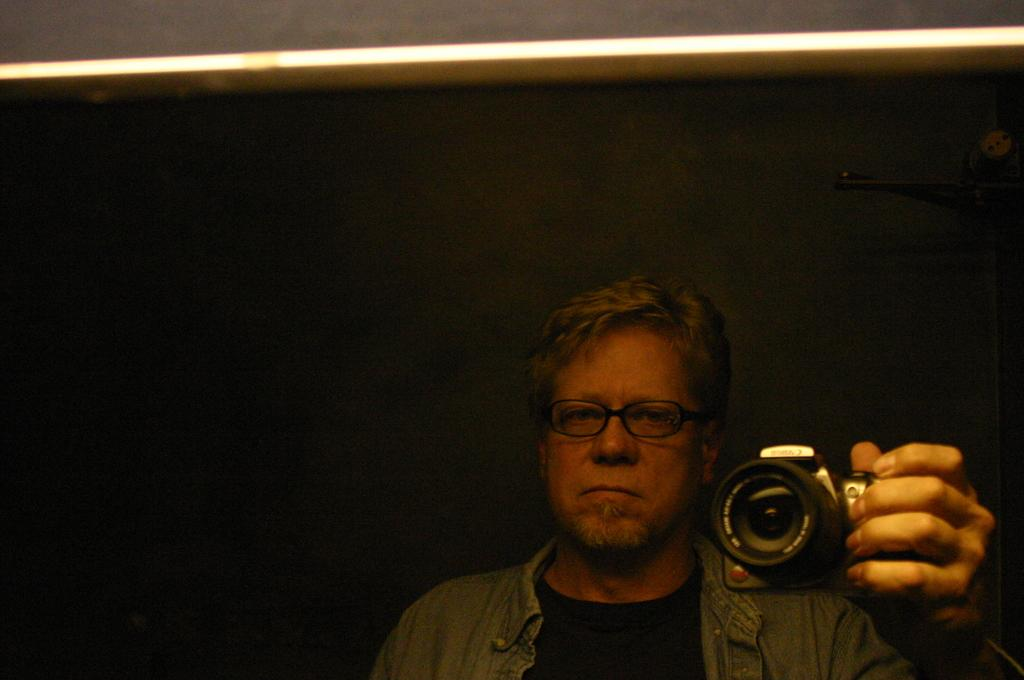What is the person holding in the image? The person is holding a camera. Can you describe the person's appearance in the image? The person is wearing a spectacle. What is the person's focus or attention in the image? The person's gaze is directed to the side. What activity is the person participating in on this particular day, as depicted in the image? The image does not provide information about the day or the activity the person is participating in. 